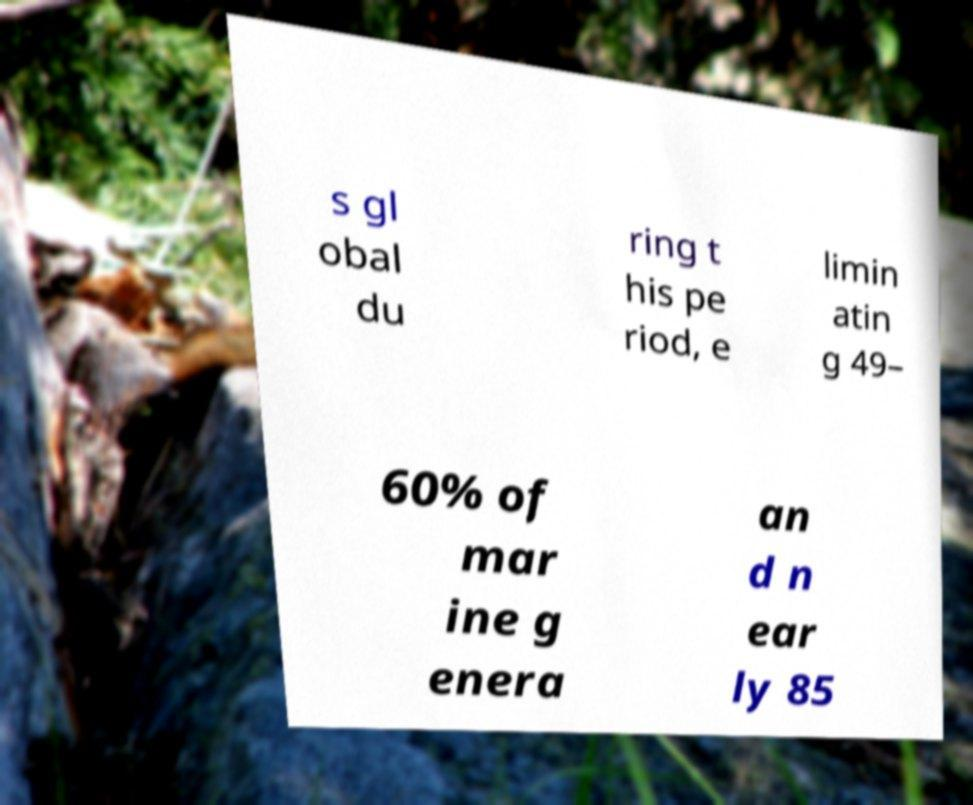Please identify and transcribe the text found in this image. s gl obal du ring t his pe riod, e limin atin g 49– 60% of mar ine g enera an d n ear ly 85 